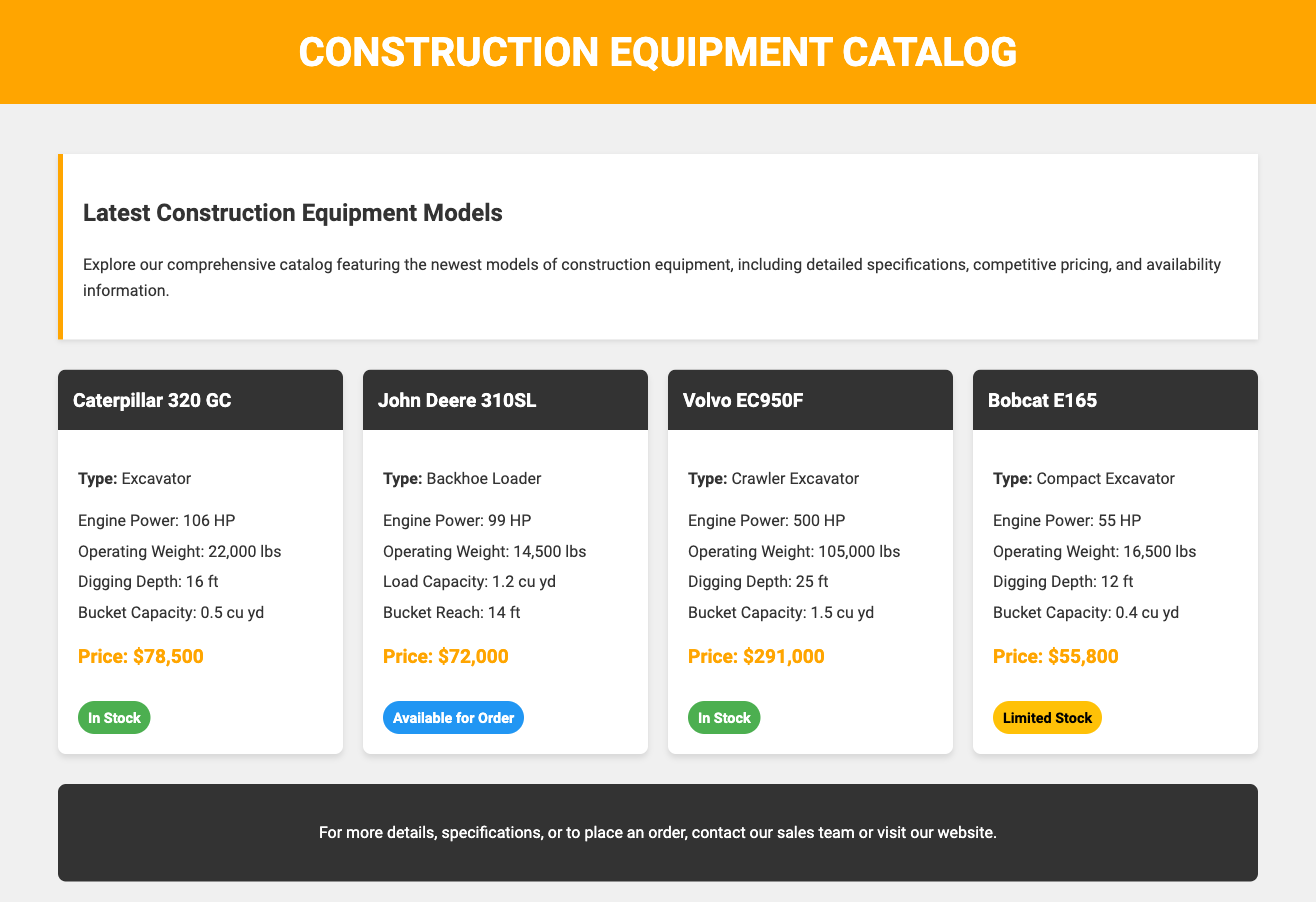What is the price of Caterpillar 320 GC? The price of Caterpillar 320 GC is stated in the document as $78,500.
Answer: $78,500 What is the engine power of Volvo EC950F? The engine power of Volvo EC950F is listed in the specifications in the document as 500 HP.
Answer: 500 HP Which equipment is available for order? The document specifies that John Deere 310SL is available for order.
Answer: John Deere 310SL What is the operating weight of Bobcat E165? The operating weight of Bobcat E165 is provided in the specifications as 16,500 lbs.
Answer: 16,500 lbs How many models are listed in the catalog? The document lists a total of four models of construction equipment.
Answer: Four models What type of equipment is the John Deere 310SL? The type of equipment for John Deere 310SL is a Backhoe Loader, as mentioned in the document.
Answer: Backhoe Loader What is the availability status of Volvo EC950F? The availability status of Volvo EC950F is mentioned as "In Stock" in the document.
Answer: In Stock What is the digging depth of Caterpillar 320 GC? The digging depth of Caterpillar 320 GC is specified in the document as 16 ft.
Answer: 16 ft What is the bucket capacity of Volvo EC950F? The bucket capacity of Volvo EC950F is stated as 1.5 cu yd in the document.
Answer: 1.5 cu yd 